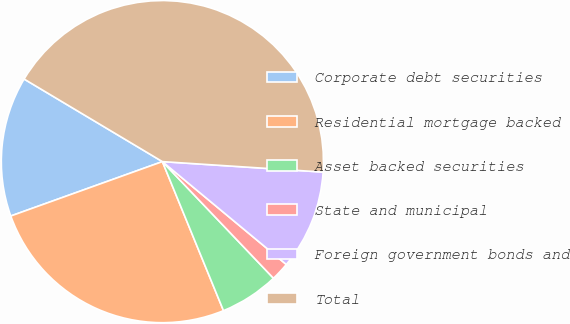<chart> <loc_0><loc_0><loc_500><loc_500><pie_chart><fcel>Corporate debt securities<fcel>Residential mortgage backed<fcel>Asset backed securities<fcel>State and municipal<fcel>Foreign government bonds and<fcel>Total<nl><fcel>14.05%<fcel>25.71%<fcel>5.92%<fcel>1.86%<fcel>9.99%<fcel>42.47%<nl></chart> 